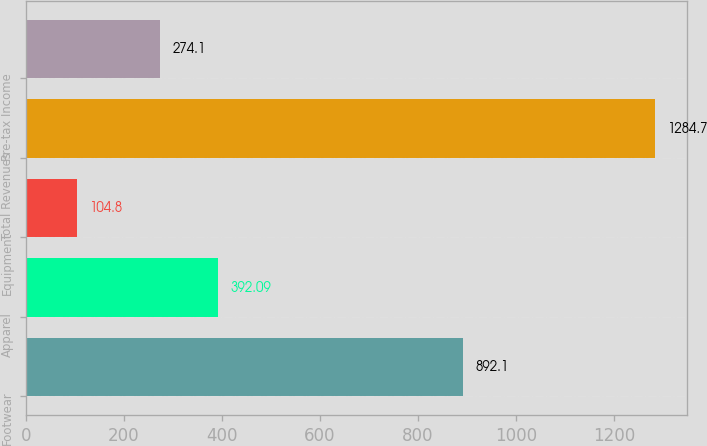Convert chart to OTSL. <chart><loc_0><loc_0><loc_500><loc_500><bar_chart><fcel>Footwear<fcel>Apparel<fcel>Equipment<fcel>Total Revenues<fcel>Pre-tax Income<nl><fcel>892.1<fcel>392.09<fcel>104.8<fcel>1284.7<fcel>274.1<nl></chart> 